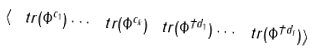<formula> <loc_0><loc_0><loc_500><loc_500>\langle \ t r ( \Phi ^ { c _ { 1 } } ) \cdots \ t r ( \Phi ^ { c _ { k } } ) \ t r ( \Phi ^ { \dagger d _ { 1 } } ) \cdots \ t r ( \Phi ^ { \dagger d _ { l } } ) \rangle</formula> 